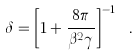Convert formula to latex. <formula><loc_0><loc_0><loc_500><loc_500>\delta = \left [ 1 + \frac { 8 \pi } { \beta ^ { 2 } \gamma } \right ] ^ { - 1 } \ .</formula> 